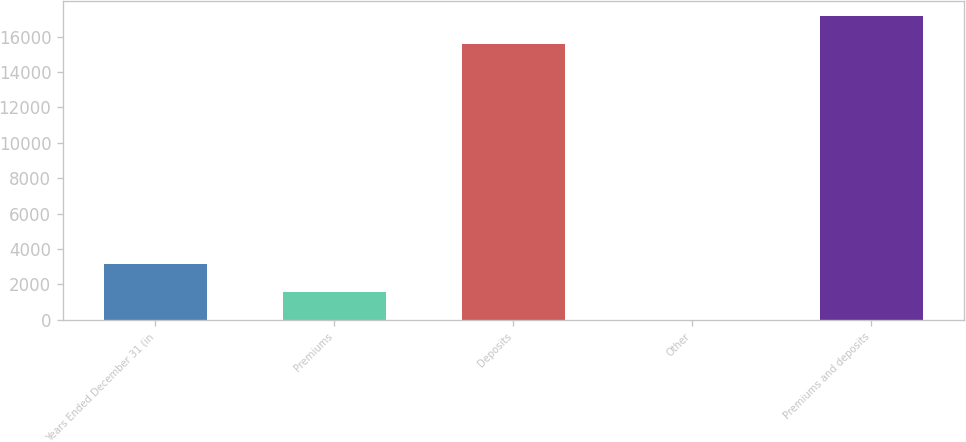<chart> <loc_0><loc_0><loc_500><loc_500><bar_chart><fcel>Years Ended December 31 (in<fcel>Premiums<fcel>Deposits<fcel>Other<fcel>Premiums and deposits<nl><fcel>3130.6<fcel>1569.3<fcel>15577<fcel>8<fcel>17138.3<nl></chart> 